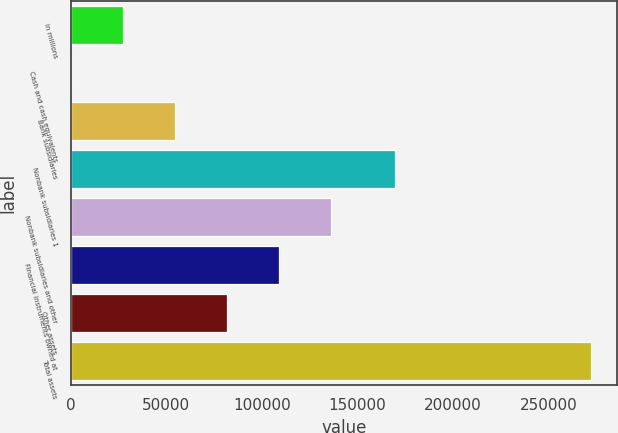Convert chart to OTSL. <chart><loc_0><loc_0><loc_500><loc_500><bar_chart><fcel>in millions<fcel>Cash and cash equivalents<fcel>Bank subsidiaries<fcel>Nonbank subsidiaries 1<fcel>Nonbank subsidiaries and other<fcel>Financial instruments owned at<fcel>Other assets<fcel>Total assets<nl><fcel>27222.3<fcel>17<fcel>54427.6<fcel>169653<fcel>136044<fcel>108838<fcel>81632.9<fcel>272070<nl></chart> 